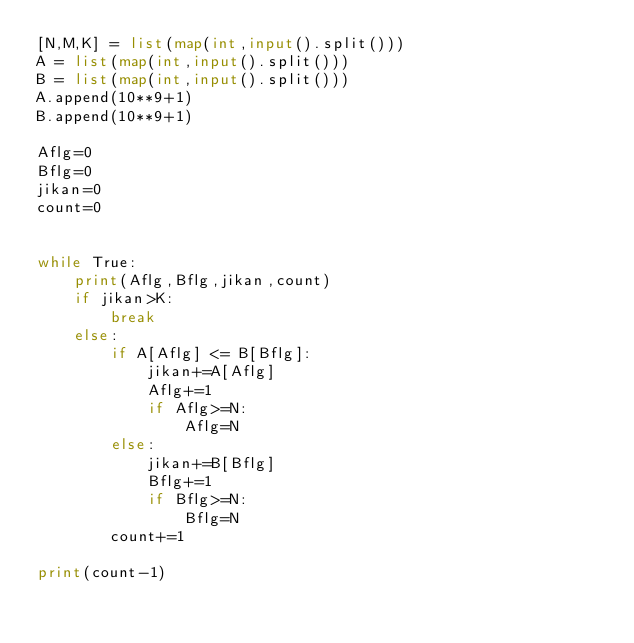Convert code to text. <code><loc_0><loc_0><loc_500><loc_500><_Python_>[N,M,K] = list(map(int,input().split()))
A = list(map(int,input().split()))
B = list(map(int,input().split()))
A.append(10**9+1)
B.append(10**9+1)

Aflg=0
Bflg=0
jikan=0
count=0


while True:
    print(Aflg,Bflg,jikan,count)
    if jikan>K:
        break
    else:
        if A[Aflg] <= B[Bflg]:
            jikan+=A[Aflg]
            Aflg+=1
            if Aflg>=N:
                Aflg=N
        else:
            jikan+=B[Bflg]
            Bflg+=1
            if Bflg>=N:
                Bflg=N
        count+=1

print(count-1)
</code> 